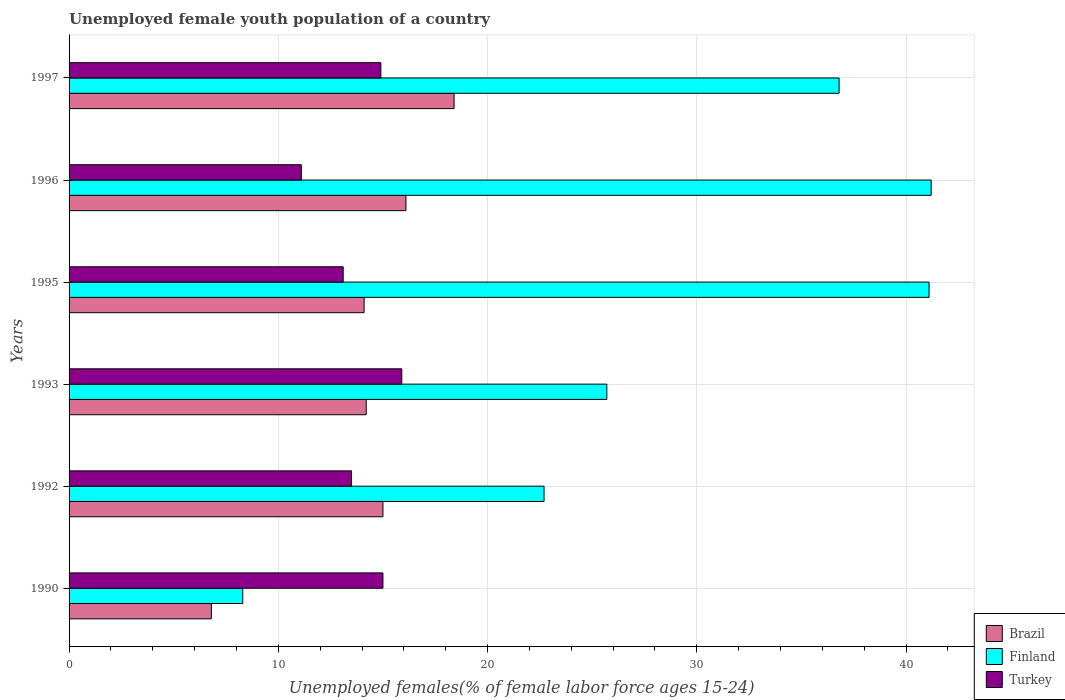How many different coloured bars are there?
Provide a short and direct response. 3. How many bars are there on the 1st tick from the bottom?
Keep it short and to the point. 3. What is the label of the 4th group of bars from the top?
Provide a succinct answer. 1993. In how many cases, is the number of bars for a given year not equal to the number of legend labels?
Your answer should be very brief. 0. Across all years, what is the maximum percentage of unemployed female youth population in Finland?
Your response must be concise. 41.2. Across all years, what is the minimum percentage of unemployed female youth population in Finland?
Offer a very short reply. 8.3. What is the total percentage of unemployed female youth population in Turkey in the graph?
Ensure brevity in your answer.  83.5. What is the difference between the percentage of unemployed female youth population in Turkey in 1992 and that in 1996?
Your answer should be compact. 2.4. What is the difference between the percentage of unemployed female youth population in Brazil in 1995 and the percentage of unemployed female youth population in Turkey in 1997?
Provide a short and direct response. -0.8. What is the average percentage of unemployed female youth population in Turkey per year?
Your response must be concise. 13.92. In the year 1993, what is the difference between the percentage of unemployed female youth population in Brazil and percentage of unemployed female youth population in Finland?
Your answer should be compact. -11.5. What is the ratio of the percentage of unemployed female youth population in Turkey in 1996 to that in 1997?
Provide a short and direct response. 0.74. Is the percentage of unemployed female youth population in Finland in 1990 less than that in 1992?
Offer a terse response. Yes. What is the difference between the highest and the second highest percentage of unemployed female youth population in Turkey?
Ensure brevity in your answer.  0.9. What is the difference between the highest and the lowest percentage of unemployed female youth population in Turkey?
Your response must be concise. 4.8. What does the 1st bar from the top in 1997 represents?
Ensure brevity in your answer.  Turkey. Is it the case that in every year, the sum of the percentage of unemployed female youth population in Turkey and percentage of unemployed female youth population in Brazil is greater than the percentage of unemployed female youth population in Finland?
Offer a very short reply. No. How many bars are there?
Give a very brief answer. 18. How many years are there in the graph?
Your answer should be very brief. 6. What is the difference between two consecutive major ticks on the X-axis?
Give a very brief answer. 10. Are the values on the major ticks of X-axis written in scientific E-notation?
Provide a short and direct response. No. Does the graph contain any zero values?
Provide a succinct answer. No. How are the legend labels stacked?
Make the answer very short. Vertical. What is the title of the graph?
Give a very brief answer. Unemployed female youth population of a country. What is the label or title of the X-axis?
Your response must be concise. Unemployed females(% of female labor force ages 15-24). What is the label or title of the Y-axis?
Your response must be concise. Years. What is the Unemployed females(% of female labor force ages 15-24) of Brazil in 1990?
Keep it short and to the point. 6.8. What is the Unemployed females(% of female labor force ages 15-24) in Finland in 1990?
Keep it short and to the point. 8.3. What is the Unemployed females(% of female labor force ages 15-24) in Turkey in 1990?
Provide a succinct answer. 15. What is the Unemployed females(% of female labor force ages 15-24) in Brazil in 1992?
Provide a short and direct response. 15. What is the Unemployed females(% of female labor force ages 15-24) in Finland in 1992?
Provide a short and direct response. 22.7. What is the Unemployed females(% of female labor force ages 15-24) of Turkey in 1992?
Provide a short and direct response. 13.5. What is the Unemployed females(% of female labor force ages 15-24) of Brazil in 1993?
Make the answer very short. 14.2. What is the Unemployed females(% of female labor force ages 15-24) in Finland in 1993?
Keep it short and to the point. 25.7. What is the Unemployed females(% of female labor force ages 15-24) in Turkey in 1993?
Give a very brief answer. 15.9. What is the Unemployed females(% of female labor force ages 15-24) in Brazil in 1995?
Your response must be concise. 14.1. What is the Unemployed females(% of female labor force ages 15-24) of Finland in 1995?
Your response must be concise. 41.1. What is the Unemployed females(% of female labor force ages 15-24) in Turkey in 1995?
Keep it short and to the point. 13.1. What is the Unemployed females(% of female labor force ages 15-24) of Brazil in 1996?
Your answer should be compact. 16.1. What is the Unemployed females(% of female labor force ages 15-24) in Finland in 1996?
Offer a terse response. 41.2. What is the Unemployed females(% of female labor force ages 15-24) in Turkey in 1996?
Your response must be concise. 11.1. What is the Unemployed females(% of female labor force ages 15-24) of Brazil in 1997?
Keep it short and to the point. 18.4. What is the Unemployed females(% of female labor force ages 15-24) in Finland in 1997?
Your answer should be compact. 36.8. What is the Unemployed females(% of female labor force ages 15-24) of Turkey in 1997?
Offer a very short reply. 14.9. Across all years, what is the maximum Unemployed females(% of female labor force ages 15-24) in Brazil?
Give a very brief answer. 18.4. Across all years, what is the maximum Unemployed females(% of female labor force ages 15-24) in Finland?
Make the answer very short. 41.2. Across all years, what is the maximum Unemployed females(% of female labor force ages 15-24) of Turkey?
Your response must be concise. 15.9. Across all years, what is the minimum Unemployed females(% of female labor force ages 15-24) in Brazil?
Offer a terse response. 6.8. Across all years, what is the minimum Unemployed females(% of female labor force ages 15-24) in Finland?
Give a very brief answer. 8.3. Across all years, what is the minimum Unemployed females(% of female labor force ages 15-24) in Turkey?
Your response must be concise. 11.1. What is the total Unemployed females(% of female labor force ages 15-24) in Brazil in the graph?
Your answer should be compact. 84.6. What is the total Unemployed females(% of female labor force ages 15-24) of Finland in the graph?
Offer a very short reply. 175.8. What is the total Unemployed females(% of female labor force ages 15-24) of Turkey in the graph?
Give a very brief answer. 83.5. What is the difference between the Unemployed females(% of female labor force ages 15-24) in Finland in 1990 and that in 1992?
Your response must be concise. -14.4. What is the difference between the Unemployed females(% of female labor force ages 15-24) in Brazil in 1990 and that in 1993?
Keep it short and to the point. -7.4. What is the difference between the Unemployed females(% of female labor force ages 15-24) in Finland in 1990 and that in 1993?
Your answer should be very brief. -17.4. What is the difference between the Unemployed females(% of female labor force ages 15-24) of Turkey in 1990 and that in 1993?
Your response must be concise. -0.9. What is the difference between the Unemployed females(% of female labor force ages 15-24) in Finland in 1990 and that in 1995?
Provide a short and direct response. -32.8. What is the difference between the Unemployed females(% of female labor force ages 15-24) of Turkey in 1990 and that in 1995?
Provide a short and direct response. 1.9. What is the difference between the Unemployed females(% of female labor force ages 15-24) of Brazil in 1990 and that in 1996?
Provide a short and direct response. -9.3. What is the difference between the Unemployed females(% of female labor force ages 15-24) of Finland in 1990 and that in 1996?
Your answer should be very brief. -32.9. What is the difference between the Unemployed females(% of female labor force ages 15-24) of Finland in 1990 and that in 1997?
Keep it short and to the point. -28.5. What is the difference between the Unemployed females(% of female labor force ages 15-24) in Finland in 1992 and that in 1993?
Give a very brief answer. -3. What is the difference between the Unemployed females(% of female labor force ages 15-24) of Finland in 1992 and that in 1995?
Make the answer very short. -18.4. What is the difference between the Unemployed females(% of female labor force ages 15-24) of Turkey in 1992 and that in 1995?
Ensure brevity in your answer.  0.4. What is the difference between the Unemployed females(% of female labor force ages 15-24) in Brazil in 1992 and that in 1996?
Provide a succinct answer. -1.1. What is the difference between the Unemployed females(% of female labor force ages 15-24) in Finland in 1992 and that in 1996?
Offer a very short reply. -18.5. What is the difference between the Unemployed females(% of female labor force ages 15-24) in Brazil in 1992 and that in 1997?
Ensure brevity in your answer.  -3.4. What is the difference between the Unemployed females(% of female labor force ages 15-24) of Finland in 1992 and that in 1997?
Ensure brevity in your answer.  -14.1. What is the difference between the Unemployed females(% of female labor force ages 15-24) of Turkey in 1992 and that in 1997?
Your response must be concise. -1.4. What is the difference between the Unemployed females(% of female labor force ages 15-24) in Brazil in 1993 and that in 1995?
Your answer should be very brief. 0.1. What is the difference between the Unemployed females(% of female labor force ages 15-24) of Finland in 1993 and that in 1995?
Keep it short and to the point. -15.4. What is the difference between the Unemployed females(% of female labor force ages 15-24) in Turkey in 1993 and that in 1995?
Provide a short and direct response. 2.8. What is the difference between the Unemployed females(% of female labor force ages 15-24) in Finland in 1993 and that in 1996?
Keep it short and to the point. -15.5. What is the difference between the Unemployed females(% of female labor force ages 15-24) of Finland in 1993 and that in 1997?
Your answer should be very brief. -11.1. What is the difference between the Unemployed females(% of female labor force ages 15-24) of Brazil in 1995 and that in 1996?
Give a very brief answer. -2. What is the difference between the Unemployed females(% of female labor force ages 15-24) of Finland in 1995 and that in 1996?
Your answer should be very brief. -0.1. What is the difference between the Unemployed females(% of female labor force ages 15-24) in Finland in 1995 and that in 1997?
Give a very brief answer. 4.3. What is the difference between the Unemployed females(% of female labor force ages 15-24) of Turkey in 1995 and that in 1997?
Keep it short and to the point. -1.8. What is the difference between the Unemployed females(% of female labor force ages 15-24) in Finland in 1996 and that in 1997?
Give a very brief answer. 4.4. What is the difference between the Unemployed females(% of female labor force ages 15-24) of Turkey in 1996 and that in 1997?
Ensure brevity in your answer.  -3.8. What is the difference between the Unemployed females(% of female labor force ages 15-24) of Brazil in 1990 and the Unemployed females(% of female labor force ages 15-24) of Finland in 1992?
Offer a terse response. -15.9. What is the difference between the Unemployed females(% of female labor force ages 15-24) of Brazil in 1990 and the Unemployed females(% of female labor force ages 15-24) of Finland in 1993?
Your answer should be very brief. -18.9. What is the difference between the Unemployed females(% of female labor force ages 15-24) of Brazil in 1990 and the Unemployed females(% of female labor force ages 15-24) of Turkey in 1993?
Offer a very short reply. -9.1. What is the difference between the Unemployed females(% of female labor force ages 15-24) of Brazil in 1990 and the Unemployed females(% of female labor force ages 15-24) of Finland in 1995?
Your answer should be very brief. -34.3. What is the difference between the Unemployed females(% of female labor force ages 15-24) of Brazil in 1990 and the Unemployed females(% of female labor force ages 15-24) of Turkey in 1995?
Keep it short and to the point. -6.3. What is the difference between the Unemployed females(% of female labor force ages 15-24) of Finland in 1990 and the Unemployed females(% of female labor force ages 15-24) of Turkey in 1995?
Make the answer very short. -4.8. What is the difference between the Unemployed females(% of female labor force ages 15-24) in Brazil in 1990 and the Unemployed females(% of female labor force ages 15-24) in Finland in 1996?
Offer a very short reply. -34.4. What is the difference between the Unemployed females(% of female labor force ages 15-24) in Brazil in 1990 and the Unemployed females(% of female labor force ages 15-24) in Turkey in 1996?
Give a very brief answer. -4.3. What is the difference between the Unemployed females(% of female labor force ages 15-24) of Brazil in 1990 and the Unemployed females(% of female labor force ages 15-24) of Turkey in 1997?
Provide a short and direct response. -8.1. What is the difference between the Unemployed females(% of female labor force ages 15-24) of Finland in 1992 and the Unemployed females(% of female labor force ages 15-24) of Turkey in 1993?
Make the answer very short. 6.8. What is the difference between the Unemployed females(% of female labor force ages 15-24) in Brazil in 1992 and the Unemployed females(% of female labor force ages 15-24) in Finland in 1995?
Ensure brevity in your answer.  -26.1. What is the difference between the Unemployed females(% of female labor force ages 15-24) of Brazil in 1992 and the Unemployed females(% of female labor force ages 15-24) of Finland in 1996?
Your answer should be compact. -26.2. What is the difference between the Unemployed females(% of female labor force ages 15-24) in Brazil in 1992 and the Unemployed females(% of female labor force ages 15-24) in Finland in 1997?
Ensure brevity in your answer.  -21.8. What is the difference between the Unemployed females(% of female labor force ages 15-24) in Finland in 1992 and the Unemployed females(% of female labor force ages 15-24) in Turkey in 1997?
Your response must be concise. 7.8. What is the difference between the Unemployed females(% of female labor force ages 15-24) in Brazil in 1993 and the Unemployed females(% of female labor force ages 15-24) in Finland in 1995?
Ensure brevity in your answer.  -26.9. What is the difference between the Unemployed females(% of female labor force ages 15-24) in Finland in 1993 and the Unemployed females(% of female labor force ages 15-24) in Turkey in 1995?
Keep it short and to the point. 12.6. What is the difference between the Unemployed females(% of female labor force ages 15-24) in Brazil in 1993 and the Unemployed females(% of female labor force ages 15-24) in Finland in 1997?
Offer a terse response. -22.6. What is the difference between the Unemployed females(% of female labor force ages 15-24) in Brazil in 1993 and the Unemployed females(% of female labor force ages 15-24) in Turkey in 1997?
Offer a terse response. -0.7. What is the difference between the Unemployed females(% of female labor force ages 15-24) in Brazil in 1995 and the Unemployed females(% of female labor force ages 15-24) in Finland in 1996?
Make the answer very short. -27.1. What is the difference between the Unemployed females(% of female labor force ages 15-24) in Brazil in 1995 and the Unemployed females(% of female labor force ages 15-24) in Finland in 1997?
Provide a succinct answer. -22.7. What is the difference between the Unemployed females(% of female labor force ages 15-24) in Finland in 1995 and the Unemployed females(% of female labor force ages 15-24) in Turkey in 1997?
Give a very brief answer. 26.2. What is the difference between the Unemployed females(% of female labor force ages 15-24) of Brazil in 1996 and the Unemployed females(% of female labor force ages 15-24) of Finland in 1997?
Your response must be concise. -20.7. What is the difference between the Unemployed females(% of female labor force ages 15-24) in Finland in 1996 and the Unemployed females(% of female labor force ages 15-24) in Turkey in 1997?
Give a very brief answer. 26.3. What is the average Unemployed females(% of female labor force ages 15-24) of Finland per year?
Offer a terse response. 29.3. What is the average Unemployed females(% of female labor force ages 15-24) in Turkey per year?
Provide a succinct answer. 13.92. In the year 1990, what is the difference between the Unemployed females(% of female labor force ages 15-24) in Brazil and Unemployed females(% of female labor force ages 15-24) in Finland?
Keep it short and to the point. -1.5. In the year 1992, what is the difference between the Unemployed females(% of female labor force ages 15-24) of Finland and Unemployed females(% of female labor force ages 15-24) of Turkey?
Keep it short and to the point. 9.2. In the year 1995, what is the difference between the Unemployed females(% of female labor force ages 15-24) in Brazil and Unemployed females(% of female labor force ages 15-24) in Finland?
Provide a succinct answer. -27. In the year 1995, what is the difference between the Unemployed females(% of female labor force ages 15-24) in Brazil and Unemployed females(% of female labor force ages 15-24) in Turkey?
Your answer should be compact. 1. In the year 1995, what is the difference between the Unemployed females(% of female labor force ages 15-24) of Finland and Unemployed females(% of female labor force ages 15-24) of Turkey?
Your answer should be very brief. 28. In the year 1996, what is the difference between the Unemployed females(% of female labor force ages 15-24) of Brazil and Unemployed females(% of female labor force ages 15-24) of Finland?
Your answer should be very brief. -25.1. In the year 1996, what is the difference between the Unemployed females(% of female labor force ages 15-24) of Finland and Unemployed females(% of female labor force ages 15-24) of Turkey?
Provide a succinct answer. 30.1. In the year 1997, what is the difference between the Unemployed females(% of female labor force ages 15-24) in Brazil and Unemployed females(% of female labor force ages 15-24) in Finland?
Keep it short and to the point. -18.4. In the year 1997, what is the difference between the Unemployed females(% of female labor force ages 15-24) of Brazil and Unemployed females(% of female labor force ages 15-24) of Turkey?
Your response must be concise. 3.5. In the year 1997, what is the difference between the Unemployed females(% of female labor force ages 15-24) in Finland and Unemployed females(% of female labor force ages 15-24) in Turkey?
Make the answer very short. 21.9. What is the ratio of the Unemployed females(% of female labor force ages 15-24) of Brazil in 1990 to that in 1992?
Provide a short and direct response. 0.45. What is the ratio of the Unemployed females(% of female labor force ages 15-24) in Finland in 1990 to that in 1992?
Your response must be concise. 0.37. What is the ratio of the Unemployed females(% of female labor force ages 15-24) of Turkey in 1990 to that in 1992?
Give a very brief answer. 1.11. What is the ratio of the Unemployed females(% of female labor force ages 15-24) in Brazil in 1990 to that in 1993?
Provide a succinct answer. 0.48. What is the ratio of the Unemployed females(% of female labor force ages 15-24) of Finland in 1990 to that in 1993?
Your response must be concise. 0.32. What is the ratio of the Unemployed females(% of female labor force ages 15-24) of Turkey in 1990 to that in 1993?
Provide a succinct answer. 0.94. What is the ratio of the Unemployed females(% of female labor force ages 15-24) of Brazil in 1990 to that in 1995?
Your response must be concise. 0.48. What is the ratio of the Unemployed females(% of female labor force ages 15-24) of Finland in 1990 to that in 1995?
Provide a short and direct response. 0.2. What is the ratio of the Unemployed females(% of female labor force ages 15-24) in Turkey in 1990 to that in 1995?
Your response must be concise. 1.15. What is the ratio of the Unemployed females(% of female labor force ages 15-24) of Brazil in 1990 to that in 1996?
Make the answer very short. 0.42. What is the ratio of the Unemployed females(% of female labor force ages 15-24) in Finland in 1990 to that in 1996?
Offer a very short reply. 0.2. What is the ratio of the Unemployed females(% of female labor force ages 15-24) of Turkey in 1990 to that in 1996?
Provide a succinct answer. 1.35. What is the ratio of the Unemployed females(% of female labor force ages 15-24) in Brazil in 1990 to that in 1997?
Your answer should be compact. 0.37. What is the ratio of the Unemployed females(% of female labor force ages 15-24) of Finland in 1990 to that in 1997?
Keep it short and to the point. 0.23. What is the ratio of the Unemployed females(% of female labor force ages 15-24) in Turkey in 1990 to that in 1997?
Keep it short and to the point. 1.01. What is the ratio of the Unemployed females(% of female labor force ages 15-24) in Brazil in 1992 to that in 1993?
Give a very brief answer. 1.06. What is the ratio of the Unemployed females(% of female labor force ages 15-24) in Finland in 1992 to that in 1993?
Your answer should be compact. 0.88. What is the ratio of the Unemployed females(% of female labor force ages 15-24) of Turkey in 1992 to that in 1993?
Give a very brief answer. 0.85. What is the ratio of the Unemployed females(% of female labor force ages 15-24) in Brazil in 1992 to that in 1995?
Give a very brief answer. 1.06. What is the ratio of the Unemployed females(% of female labor force ages 15-24) of Finland in 1992 to that in 1995?
Keep it short and to the point. 0.55. What is the ratio of the Unemployed females(% of female labor force ages 15-24) of Turkey in 1992 to that in 1995?
Provide a short and direct response. 1.03. What is the ratio of the Unemployed females(% of female labor force ages 15-24) in Brazil in 1992 to that in 1996?
Make the answer very short. 0.93. What is the ratio of the Unemployed females(% of female labor force ages 15-24) in Finland in 1992 to that in 1996?
Your answer should be very brief. 0.55. What is the ratio of the Unemployed females(% of female labor force ages 15-24) in Turkey in 1992 to that in 1996?
Your answer should be very brief. 1.22. What is the ratio of the Unemployed females(% of female labor force ages 15-24) in Brazil in 1992 to that in 1997?
Give a very brief answer. 0.82. What is the ratio of the Unemployed females(% of female labor force ages 15-24) in Finland in 1992 to that in 1997?
Offer a terse response. 0.62. What is the ratio of the Unemployed females(% of female labor force ages 15-24) in Turkey in 1992 to that in 1997?
Provide a short and direct response. 0.91. What is the ratio of the Unemployed females(% of female labor force ages 15-24) of Brazil in 1993 to that in 1995?
Ensure brevity in your answer.  1.01. What is the ratio of the Unemployed females(% of female labor force ages 15-24) in Finland in 1993 to that in 1995?
Give a very brief answer. 0.63. What is the ratio of the Unemployed females(% of female labor force ages 15-24) of Turkey in 1993 to that in 1995?
Your answer should be very brief. 1.21. What is the ratio of the Unemployed females(% of female labor force ages 15-24) of Brazil in 1993 to that in 1996?
Your answer should be very brief. 0.88. What is the ratio of the Unemployed females(% of female labor force ages 15-24) of Finland in 1993 to that in 1996?
Make the answer very short. 0.62. What is the ratio of the Unemployed females(% of female labor force ages 15-24) in Turkey in 1993 to that in 1996?
Your response must be concise. 1.43. What is the ratio of the Unemployed females(% of female labor force ages 15-24) in Brazil in 1993 to that in 1997?
Your response must be concise. 0.77. What is the ratio of the Unemployed females(% of female labor force ages 15-24) in Finland in 1993 to that in 1997?
Make the answer very short. 0.7. What is the ratio of the Unemployed females(% of female labor force ages 15-24) in Turkey in 1993 to that in 1997?
Offer a very short reply. 1.07. What is the ratio of the Unemployed females(% of female labor force ages 15-24) of Brazil in 1995 to that in 1996?
Ensure brevity in your answer.  0.88. What is the ratio of the Unemployed females(% of female labor force ages 15-24) of Turkey in 1995 to that in 1996?
Offer a terse response. 1.18. What is the ratio of the Unemployed females(% of female labor force ages 15-24) in Brazil in 1995 to that in 1997?
Offer a terse response. 0.77. What is the ratio of the Unemployed females(% of female labor force ages 15-24) in Finland in 1995 to that in 1997?
Your answer should be very brief. 1.12. What is the ratio of the Unemployed females(% of female labor force ages 15-24) of Turkey in 1995 to that in 1997?
Your answer should be very brief. 0.88. What is the ratio of the Unemployed females(% of female labor force ages 15-24) of Finland in 1996 to that in 1997?
Make the answer very short. 1.12. What is the ratio of the Unemployed females(% of female labor force ages 15-24) in Turkey in 1996 to that in 1997?
Provide a succinct answer. 0.74. What is the difference between the highest and the second highest Unemployed females(% of female labor force ages 15-24) in Brazil?
Your response must be concise. 2.3. What is the difference between the highest and the lowest Unemployed females(% of female labor force ages 15-24) in Finland?
Your response must be concise. 32.9. What is the difference between the highest and the lowest Unemployed females(% of female labor force ages 15-24) in Turkey?
Your response must be concise. 4.8. 